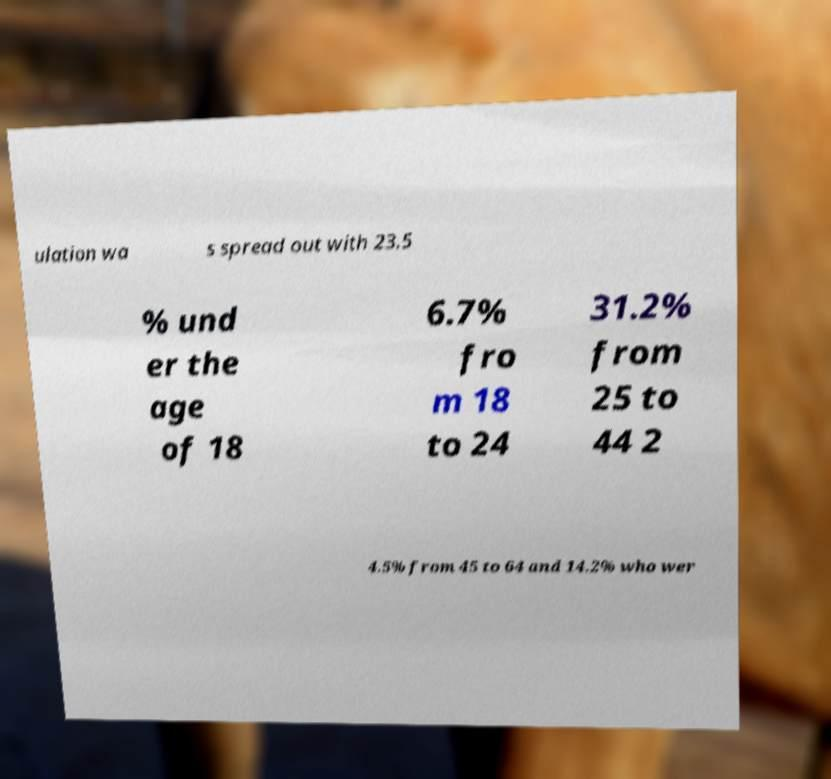Could you extract and type out the text from this image? ulation wa s spread out with 23.5 % und er the age of 18 6.7% fro m 18 to 24 31.2% from 25 to 44 2 4.5% from 45 to 64 and 14.2% who wer 